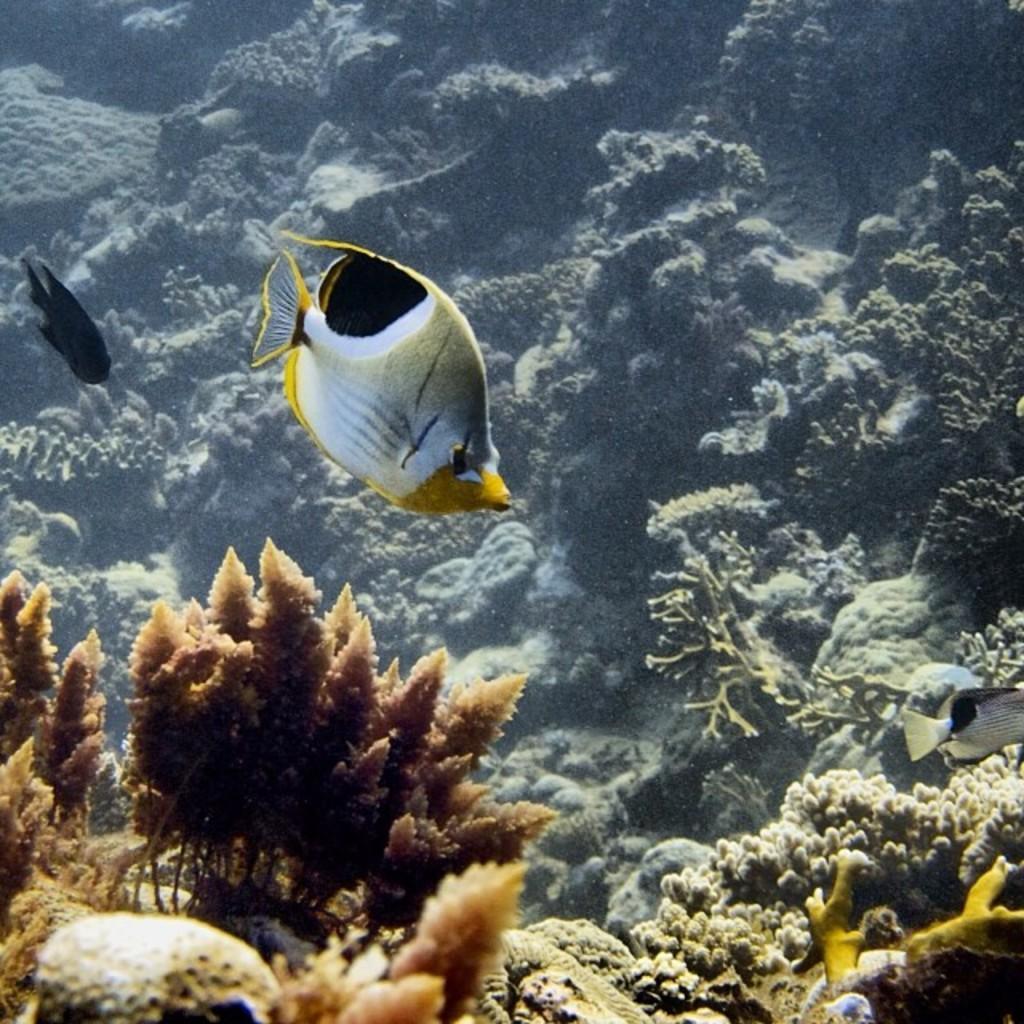In one or two sentences, can you explain what this image depicts? This image is clicked inside the water. There are fishes swimming in the water. At the bottom there are coral reefs. In the background there are marine plants. 